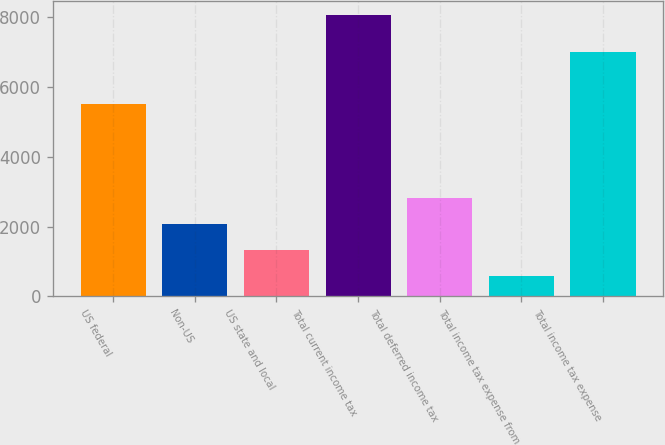Convert chart to OTSL. <chart><loc_0><loc_0><loc_500><loc_500><bar_chart><fcel>US federal<fcel>Non-US<fcel>US state and local<fcel>Total current income tax<fcel>Total deferred income tax<fcel>Total income tax expense from<fcel>Total income tax expense<nl><fcel>5512<fcel>2067<fcel>1319.5<fcel>8047<fcel>2814.5<fcel>572<fcel>7007<nl></chart> 